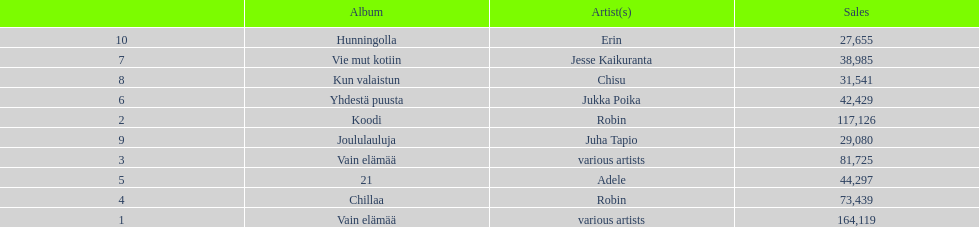Which was better selling, hunningolla or vain elamaa? Vain elämää. 